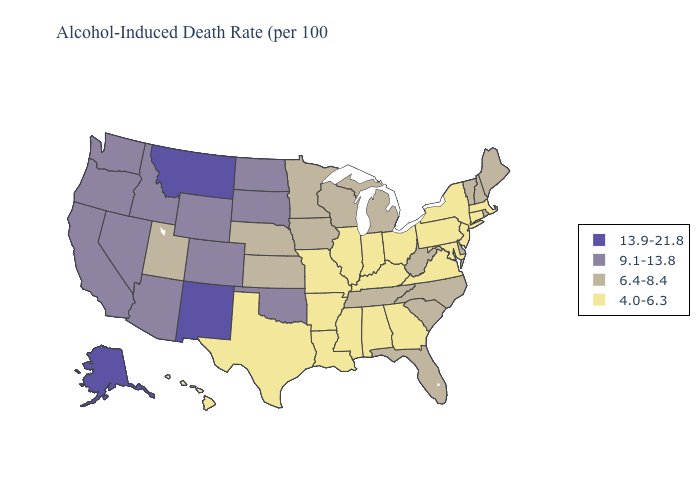What is the lowest value in the MidWest?
Give a very brief answer. 4.0-6.3. Which states hav the highest value in the MidWest?
Answer briefly. North Dakota, South Dakota. Name the states that have a value in the range 13.9-21.8?
Concise answer only. Alaska, Montana, New Mexico. What is the lowest value in states that border Wisconsin?
Concise answer only. 4.0-6.3. Which states have the lowest value in the USA?
Concise answer only. Alabama, Arkansas, Connecticut, Georgia, Hawaii, Illinois, Indiana, Kentucky, Louisiana, Maryland, Massachusetts, Mississippi, Missouri, New Jersey, New York, Ohio, Pennsylvania, Texas, Virginia. Does North Carolina have the highest value in the USA?
Concise answer only. No. Does Mississippi have the same value as Missouri?
Answer briefly. Yes. Does the map have missing data?
Short answer required. No. What is the highest value in the USA?
Answer briefly. 13.9-21.8. What is the lowest value in the Northeast?
Quick response, please. 4.0-6.3. Which states have the highest value in the USA?
Keep it brief. Alaska, Montana, New Mexico. Name the states that have a value in the range 4.0-6.3?
Write a very short answer. Alabama, Arkansas, Connecticut, Georgia, Hawaii, Illinois, Indiana, Kentucky, Louisiana, Maryland, Massachusetts, Mississippi, Missouri, New Jersey, New York, Ohio, Pennsylvania, Texas, Virginia. What is the value of Delaware?
Short answer required. 6.4-8.4. What is the value of Florida?
Concise answer only. 6.4-8.4. 